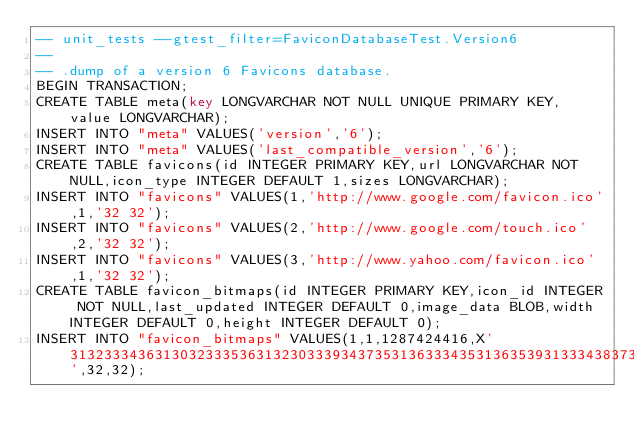<code> <loc_0><loc_0><loc_500><loc_500><_SQL_>-- unit_tests --gtest_filter=FaviconDatabaseTest.Version6
--
-- .dump of a version 6 Favicons database.
BEGIN TRANSACTION;
CREATE TABLE meta(key LONGVARCHAR NOT NULL UNIQUE PRIMARY KEY, value LONGVARCHAR);
INSERT INTO "meta" VALUES('version','6');
INSERT INTO "meta" VALUES('last_compatible_version','6');
CREATE TABLE favicons(id INTEGER PRIMARY KEY,url LONGVARCHAR NOT NULL,icon_type INTEGER DEFAULT 1,sizes LONGVARCHAR);
INSERT INTO "favicons" VALUES(1,'http://www.google.com/favicon.ico',1,'32 32');
INSERT INTO "favicons" VALUES(2,'http://www.google.com/touch.ico',2,'32 32');
INSERT INTO "favicons" VALUES(3,'http://www.yahoo.com/favicon.ico',1,'32 32');
CREATE TABLE favicon_bitmaps(id INTEGER PRIMARY KEY,icon_id INTEGER NOT NULL,last_updated INTEGER DEFAULT 0,image_data BLOB,width INTEGER DEFAULT 0,height INTEGER DEFAULT 0);
INSERT INTO "favicon_bitmaps" VALUES(1,1,1287424416,X'313233343631303233353631323033393437353136333435313635393133343837313034373831323336343931363534313932333435313932333435313233343931333400',32,32);</code> 